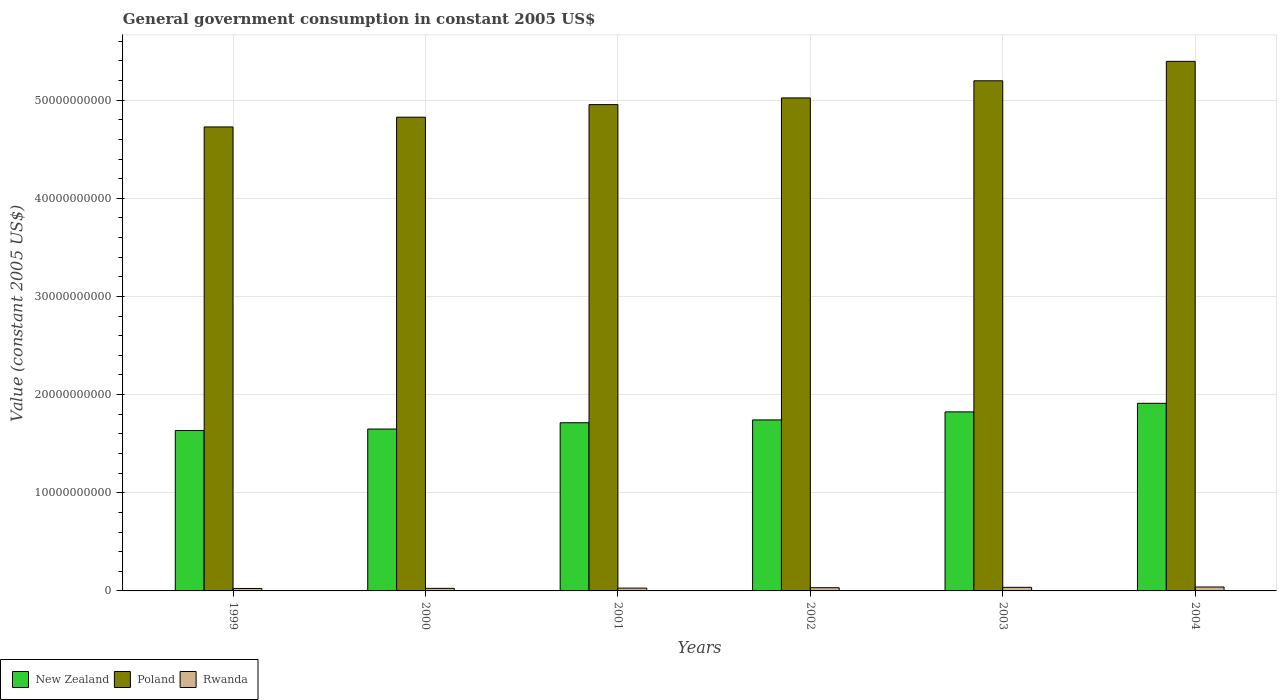How many different coloured bars are there?
Make the answer very short. 3. Are the number of bars per tick equal to the number of legend labels?
Keep it short and to the point. Yes. How many bars are there on the 6th tick from the left?
Your response must be concise. 3. What is the label of the 5th group of bars from the left?
Provide a succinct answer. 2003. What is the government conusmption in Rwanda in 2000?
Ensure brevity in your answer.  2.63e+08. Across all years, what is the maximum government conusmption in Rwanda?
Make the answer very short. 4.01e+08. Across all years, what is the minimum government conusmption in New Zealand?
Your answer should be compact. 1.63e+1. In which year was the government conusmption in New Zealand maximum?
Your answer should be compact. 2004. What is the total government conusmption in Rwanda in the graph?
Make the answer very short. 1.89e+09. What is the difference between the government conusmption in New Zealand in 1999 and that in 2002?
Ensure brevity in your answer.  -1.08e+09. What is the difference between the government conusmption in Rwanda in 1999 and the government conusmption in New Zealand in 2004?
Offer a terse response. -1.89e+1. What is the average government conusmption in New Zealand per year?
Ensure brevity in your answer.  1.75e+1. In the year 2002, what is the difference between the government conusmption in New Zealand and government conusmption in Rwanda?
Your answer should be very brief. 1.71e+1. What is the ratio of the government conusmption in Rwanda in 2001 to that in 2002?
Provide a succinct answer. 0.88. Is the difference between the government conusmption in New Zealand in 1999 and 2004 greater than the difference between the government conusmption in Rwanda in 1999 and 2004?
Your answer should be very brief. No. What is the difference between the highest and the second highest government conusmption in Rwanda?
Offer a very short reply. 3.50e+07. What is the difference between the highest and the lowest government conusmption in Rwanda?
Keep it short and to the point. 1.49e+08. In how many years, is the government conusmption in Rwanda greater than the average government conusmption in Rwanda taken over all years?
Make the answer very short. 3. Is the sum of the government conusmption in New Zealand in 1999 and 2002 greater than the maximum government conusmption in Rwanda across all years?
Give a very brief answer. Yes. What does the 2nd bar from the left in 2001 represents?
Keep it short and to the point. Poland. What does the 3rd bar from the right in 1999 represents?
Give a very brief answer. New Zealand. Are all the bars in the graph horizontal?
Make the answer very short. No. What is the difference between two consecutive major ticks on the Y-axis?
Ensure brevity in your answer.  1.00e+1. Are the values on the major ticks of Y-axis written in scientific E-notation?
Your answer should be very brief. No. Does the graph contain any zero values?
Your answer should be compact. No. Does the graph contain grids?
Provide a short and direct response. Yes. How many legend labels are there?
Make the answer very short. 3. How are the legend labels stacked?
Offer a very short reply. Horizontal. What is the title of the graph?
Give a very brief answer. General government consumption in constant 2005 US$. What is the label or title of the Y-axis?
Ensure brevity in your answer.  Value (constant 2005 US$). What is the Value (constant 2005 US$) of New Zealand in 1999?
Give a very brief answer. 1.63e+1. What is the Value (constant 2005 US$) of Poland in 1999?
Provide a short and direct response. 4.73e+1. What is the Value (constant 2005 US$) of Rwanda in 1999?
Give a very brief answer. 2.51e+08. What is the Value (constant 2005 US$) in New Zealand in 2000?
Offer a terse response. 1.65e+1. What is the Value (constant 2005 US$) of Poland in 2000?
Provide a succinct answer. 4.83e+1. What is the Value (constant 2005 US$) in Rwanda in 2000?
Your answer should be very brief. 2.63e+08. What is the Value (constant 2005 US$) in New Zealand in 2001?
Ensure brevity in your answer.  1.71e+1. What is the Value (constant 2005 US$) in Poland in 2001?
Provide a short and direct response. 4.95e+1. What is the Value (constant 2005 US$) in Rwanda in 2001?
Keep it short and to the point. 2.87e+08. What is the Value (constant 2005 US$) of New Zealand in 2002?
Offer a terse response. 1.74e+1. What is the Value (constant 2005 US$) of Poland in 2002?
Ensure brevity in your answer.  5.02e+1. What is the Value (constant 2005 US$) in Rwanda in 2002?
Your answer should be compact. 3.27e+08. What is the Value (constant 2005 US$) in New Zealand in 2003?
Keep it short and to the point. 1.82e+1. What is the Value (constant 2005 US$) of Poland in 2003?
Your response must be concise. 5.20e+1. What is the Value (constant 2005 US$) in Rwanda in 2003?
Provide a short and direct response. 3.66e+08. What is the Value (constant 2005 US$) in New Zealand in 2004?
Offer a terse response. 1.91e+1. What is the Value (constant 2005 US$) in Poland in 2004?
Provide a short and direct response. 5.39e+1. What is the Value (constant 2005 US$) of Rwanda in 2004?
Your response must be concise. 4.01e+08. Across all years, what is the maximum Value (constant 2005 US$) in New Zealand?
Provide a short and direct response. 1.91e+1. Across all years, what is the maximum Value (constant 2005 US$) in Poland?
Your answer should be very brief. 5.39e+1. Across all years, what is the maximum Value (constant 2005 US$) of Rwanda?
Provide a short and direct response. 4.01e+08. Across all years, what is the minimum Value (constant 2005 US$) of New Zealand?
Keep it short and to the point. 1.63e+1. Across all years, what is the minimum Value (constant 2005 US$) in Poland?
Offer a terse response. 4.73e+1. Across all years, what is the minimum Value (constant 2005 US$) of Rwanda?
Offer a terse response. 2.51e+08. What is the total Value (constant 2005 US$) of New Zealand in the graph?
Make the answer very short. 1.05e+11. What is the total Value (constant 2005 US$) in Poland in the graph?
Provide a short and direct response. 3.01e+11. What is the total Value (constant 2005 US$) in Rwanda in the graph?
Your answer should be compact. 1.89e+09. What is the difference between the Value (constant 2005 US$) of New Zealand in 1999 and that in 2000?
Make the answer very short. -1.54e+08. What is the difference between the Value (constant 2005 US$) of Poland in 1999 and that in 2000?
Ensure brevity in your answer.  -9.93e+08. What is the difference between the Value (constant 2005 US$) of Rwanda in 1999 and that in 2000?
Give a very brief answer. -1.11e+07. What is the difference between the Value (constant 2005 US$) in New Zealand in 1999 and that in 2001?
Offer a terse response. -7.96e+08. What is the difference between the Value (constant 2005 US$) in Poland in 1999 and that in 2001?
Keep it short and to the point. -2.27e+09. What is the difference between the Value (constant 2005 US$) in Rwanda in 1999 and that in 2001?
Offer a terse response. -3.54e+07. What is the difference between the Value (constant 2005 US$) in New Zealand in 1999 and that in 2002?
Your response must be concise. -1.08e+09. What is the difference between the Value (constant 2005 US$) of Poland in 1999 and that in 2002?
Make the answer very short. -2.96e+09. What is the difference between the Value (constant 2005 US$) of Rwanda in 1999 and that in 2002?
Give a very brief answer. -7.56e+07. What is the difference between the Value (constant 2005 US$) in New Zealand in 1999 and that in 2003?
Your answer should be compact. -1.90e+09. What is the difference between the Value (constant 2005 US$) in Poland in 1999 and that in 2003?
Make the answer very short. -4.70e+09. What is the difference between the Value (constant 2005 US$) of Rwanda in 1999 and that in 2003?
Your answer should be very brief. -1.14e+08. What is the difference between the Value (constant 2005 US$) in New Zealand in 1999 and that in 2004?
Keep it short and to the point. -2.77e+09. What is the difference between the Value (constant 2005 US$) of Poland in 1999 and that in 2004?
Provide a succinct answer. -6.68e+09. What is the difference between the Value (constant 2005 US$) of Rwanda in 1999 and that in 2004?
Your answer should be compact. -1.49e+08. What is the difference between the Value (constant 2005 US$) in New Zealand in 2000 and that in 2001?
Provide a short and direct response. -6.42e+08. What is the difference between the Value (constant 2005 US$) of Poland in 2000 and that in 2001?
Offer a terse response. -1.28e+09. What is the difference between the Value (constant 2005 US$) in Rwanda in 2000 and that in 2001?
Your answer should be very brief. -2.43e+07. What is the difference between the Value (constant 2005 US$) of New Zealand in 2000 and that in 2002?
Give a very brief answer. -9.29e+08. What is the difference between the Value (constant 2005 US$) of Poland in 2000 and that in 2002?
Keep it short and to the point. -1.96e+09. What is the difference between the Value (constant 2005 US$) of Rwanda in 2000 and that in 2002?
Ensure brevity in your answer.  -6.45e+07. What is the difference between the Value (constant 2005 US$) of New Zealand in 2000 and that in 2003?
Keep it short and to the point. -1.75e+09. What is the difference between the Value (constant 2005 US$) of Poland in 2000 and that in 2003?
Make the answer very short. -3.71e+09. What is the difference between the Value (constant 2005 US$) in Rwanda in 2000 and that in 2003?
Your answer should be compact. -1.03e+08. What is the difference between the Value (constant 2005 US$) of New Zealand in 2000 and that in 2004?
Make the answer very short. -2.62e+09. What is the difference between the Value (constant 2005 US$) in Poland in 2000 and that in 2004?
Provide a short and direct response. -5.69e+09. What is the difference between the Value (constant 2005 US$) of Rwanda in 2000 and that in 2004?
Make the answer very short. -1.38e+08. What is the difference between the Value (constant 2005 US$) of New Zealand in 2001 and that in 2002?
Make the answer very short. -2.88e+08. What is the difference between the Value (constant 2005 US$) of Poland in 2001 and that in 2002?
Your answer should be very brief. -6.83e+08. What is the difference between the Value (constant 2005 US$) of Rwanda in 2001 and that in 2002?
Keep it short and to the point. -4.02e+07. What is the difference between the Value (constant 2005 US$) of New Zealand in 2001 and that in 2003?
Make the answer very short. -1.11e+09. What is the difference between the Value (constant 2005 US$) of Poland in 2001 and that in 2003?
Make the answer very short. -2.43e+09. What is the difference between the Value (constant 2005 US$) of Rwanda in 2001 and that in 2003?
Give a very brief answer. -7.88e+07. What is the difference between the Value (constant 2005 US$) of New Zealand in 2001 and that in 2004?
Give a very brief answer. -1.98e+09. What is the difference between the Value (constant 2005 US$) in Poland in 2001 and that in 2004?
Your answer should be compact. -4.41e+09. What is the difference between the Value (constant 2005 US$) in Rwanda in 2001 and that in 2004?
Offer a terse response. -1.14e+08. What is the difference between the Value (constant 2005 US$) of New Zealand in 2002 and that in 2003?
Your answer should be compact. -8.18e+08. What is the difference between the Value (constant 2005 US$) in Poland in 2002 and that in 2003?
Provide a short and direct response. -1.74e+09. What is the difference between the Value (constant 2005 US$) in Rwanda in 2002 and that in 2003?
Offer a very short reply. -3.86e+07. What is the difference between the Value (constant 2005 US$) in New Zealand in 2002 and that in 2004?
Give a very brief answer. -1.69e+09. What is the difference between the Value (constant 2005 US$) of Poland in 2002 and that in 2004?
Make the answer very short. -3.72e+09. What is the difference between the Value (constant 2005 US$) of Rwanda in 2002 and that in 2004?
Make the answer very short. -7.36e+07. What is the difference between the Value (constant 2005 US$) of New Zealand in 2003 and that in 2004?
Provide a short and direct response. -8.72e+08. What is the difference between the Value (constant 2005 US$) of Poland in 2003 and that in 2004?
Provide a short and direct response. -1.98e+09. What is the difference between the Value (constant 2005 US$) in Rwanda in 2003 and that in 2004?
Your response must be concise. -3.50e+07. What is the difference between the Value (constant 2005 US$) in New Zealand in 1999 and the Value (constant 2005 US$) in Poland in 2000?
Your answer should be very brief. -3.19e+1. What is the difference between the Value (constant 2005 US$) of New Zealand in 1999 and the Value (constant 2005 US$) of Rwanda in 2000?
Ensure brevity in your answer.  1.61e+1. What is the difference between the Value (constant 2005 US$) in Poland in 1999 and the Value (constant 2005 US$) in Rwanda in 2000?
Keep it short and to the point. 4.70e+1. What is the difference between the Value (constant 2005 US$) in New Zealand in 1999 and the Value (constant 2005 US$) in Poland in 2001?
Your answer should be compact. -3.32e+1. What is the difference between the Value (constant 2005 US$) of New Zealand in 1999 and the Value (constant 2005 US$) of Rwanda in 2001?
Give a very brief answer. 1.61e+1. What is the difference between the Value (constant 2005 US$) in Poland in 1999 and the Value (constant 2005 US$) in Rwanda in 2001?
Provide a succinct answer. 4.70e+1. What is the difference between the Value (constant 2005 US$) in New Zealand in 1999 and the Value (constant 2005 US$) in Poland in 2002?
Ensure brevity in your answer.  -3.39e+1. What is the difference between the Value (constant 2005 US$) of New Zealand in 1999 and the Value (constant 2005 US$) of Rwanda in 2002?
Provide a succinct answer. 1.60e+1. What is the difference between the Value (constant 2005 US$) of Poland in 1999 and the Value (constant 2005 US$) of Rwanda in 2002?
Keep it short and to the point. 4.69e+1. What is the difference between the Value (constant 2005 US$) of New Zealand in 1999 and the Value (constant 2005 US$) of Poland in 2003?
Your answer should be very brief. -3.56e+1. What is the difference between the Value (constant 2005 US$) of New Zealand in 1999 and the Value (constant 2005 US$) of Rwanda in 2003?
Provide a short and direct response. 1.60e+1. What is the difference between the Value (constant 2005 US$) in Poland in 1999 and the Value (constant 2005 US$) in Rwanda in 2003?
Your answer should be very brief. 4.69e+1. What is the difference between the Value (constant 2005 US$) of New Zealand in 1999 and the Value (constant 2005 US$) of Poland in 2004?
Offer a terse response. -3.76e+1. What is the difference between the Value (constant 2005 US$) of New Zealand in 1999 and the Value (constant 2005 US$) of Rwanda in 2004?
Your response must be concise. 1.59e+1. What is the difference between the Value (constant 2005 US$) of Poland in 1999 and the Value (constant 2005 US$) of Rwanda in 2004?
Offer a very short reply. 4.69e+1. What is the difference between the Value (constant 2005 US$) of New Zealand in 2000 and the Value (constant 2005 US$) of Poland in 2001?
Make the answer very short. -3.30e+1. What is the difference between the Value (constant 2005 US$) of New Zealand in 2000 and the Value (constant 2005 US$) of Rwanda in 2001?
Provide a succinct answer. 1.62e+1. What is the difference between the Value (constant 2005 US$) of Poland in 2000 and the Value (constant 2005 US$) of Rwanda in 2001?
Provide a short and direct response. 4.80e+1. What is the difference between the Value (constant 2005 US$) of New Zealand in 2000 and the Value (constant 2005 US$) of Poland in 2002?
Your response must be concise. -3.37e+1. What is the difference between the Value (constant 2005 US$) in New Zealand in 2000 and the Value (constant 2005 US$) in Rwanda in 2002?
Offer a terse response. 1.62e+1. What is the difference between the Value (constant 2005 US$) in Poland in 2000 and the Value (constant 2005 US$) in Rwanda in 2002?
Give a very brief answer. 4.79e+1. What is the difference between the Value (constant 2005 US$) in New Zealand in 2000 and the Value (constant 2005 US$) in Poland in 2003?
Ensure brevity in your answer.  -3.55e+1. What is the difference between the Value (constant 2005 US$) in New Zealand in 2000 and the Value (constant 2005 US$) in Rwanda in 2003?
Ensure brevity in your answer.  1.61e+1. What is the difference between the Value (constant 2005 US$) of Poland in 2000 and the Value (constant 2005 US$) of Rwanda in 2003?
Give a very brief answer. 4.79e+1. What is the difference between the Value (constant 2005 US$) of New Zealand in 2000 and the Value (constant 2005 US$) of Poland in 2004?
Your answer should be compact. -3.75e+1. What is the difference between the Value (constant 2005 US$) of New Zealand in 2000 and the Value (constant 2005 US$) of Rwanda in 2004?
Offer a very short reply. 1.61e+1. What is the difference between the Value (constant 2005 US$) of Poland in 2000 and the Value (constant 2005 US$) of Rwanda in 2004?
Make the answer very short. 4.79e+1. What is the difference between the Value (constant 2005 US$) of New Zealand in 2001 and the Value (constant 2005 US$) of Poland in 2002?
Ensure brevity in your answer.  -3.31e+1. What is the difference between the Value (constant 2005 US$) in New Zealand in 2001 and the Value (constant 2005 US$) in Rwanda in 2002?
Ensure brevity in your answer.  1.68e+1. What is the difference between the Value (constant 2005 US$) in Poland in 2001 and the Value (constant 2005 US$) in Rwanda in 2002?
Ensure brevity in your answer.  4.92e+1. What is the difference between the Value (constant 2005 US$) of New Zealand in 2001 and the Value (constant 2005 US$) of Poland in 2003?
Give a very brief answer. -3.48e+1. What is the difference between the Value (constant 2005 US$) of New Zealand in 2001 and the Value (constant 2005 US$) of Rwanda in 2003?
Offer a very short reply. 1.68e+1. What is the difference between the Value (constant 2005 US$) of Poland in 2001 and the Value (constant 2005 US$) of Rwanda in 2003?
Make the answer very short. 4.92e+1. What is the difference between the Value (constant 2005 US$) of New Zealand in 2001 and the Value (constant 2005 US$) of Poland in 2004?
Offer a very short reply. -3.68e+1. What is the difference between the Value (constant 2005 US$) in New Zealand in 2001 and the Value (constant 2005 US$) in Rwanda in 2004?
Provide a succinct answer. 1.67e+1. What is the difference between the Value (constant 2005 US$) of Poland in 2001 and the Value (constant 2005 US$) of Rwanda in 2004?
Your answer should be compact. 4.91e+1. What is the difference between the Value (constant 2005 US$) in New Zealand in 2002 and the Value (constant 2005 US$) in Poland in 2003?
Give a very brief answer. -3.45e+1. What is the difference between the Value (constant 2005 US$) in New Zealand in 2002 and the Value (constant 2005 US$) in Rwanda in 2003?
Provide a succinct answer. 1.71e+1. What is the difference between the Value (constant 2005 US$) in Poland in 2002 and the Value (constant 2005 US$) in Rwanda in 2003?
Your response must be concise. 4.99e+1. What is the difference between the Value (constant 2005 US$) of New Zealand in 2002 and the Value (constant 2005 US$) of Poland in 2004?
Your answer should be very brief. -3.65e+1. What is the difference between the Value (constant 2005 US$) of New Zealand in 2002 and the Value (constant 2005 US$) of Rwanda in 2004?
Provide a short and direct response. 1.70e+1. What is the difference between the Value (constant 2005 US$) in Poland in 2002 and the Value (constant 2005 US$) in Rwanda in 2004?
Provide a succinct answer. 4.98e+1. What is the difference between the Value (constant 2005 US$) in New Zealand in 2003 and the Value (constant 2005 US$) in Poland in 2004?
Ensure brevity in your answer.  -3.57e+1. What is the difference between the Value (constant 2005 US$) in New Zealand in 2003 and the Value (constant 2005 US$) in Rwanda in 2004?
Provide a short and direct response. 1.78e+1. What is the difference between the Value (constant 2005 US$) of Poland in 2003 and the Value (constant 2005 US$) of Rwanda in 2004?
Offer a terse response. 5.16e+1. What is the average Value (constant 2005 US$) in New Zealand per year?
Ensure brevity in your answer.  1.75e+1. What is the average Value (constant 2005 US$) in Poland per year?
Your answer should be compact. 5.02e+1. What is the average Value (constant 2005 US$) of Rwanda per year?
Offer a very short reply. 3.16e+08. In the year 1999, what is the difference between the Value (constant 2005 US$) of New Zealand and Value (constant 2005 US$) of Poland?
Keep it short and to the point. -3.09e+1. In the year 1999, what is the difference between the Value (constant 2005 US$) of New Zealand and Value (constant 2005 US$) of Rwanda?
Offer a very short reply. 1.61e+1. In the year 1999, what is the difference between the Value (constant 2005 US$) of Poland and Value (constant 2005 US$) of Rwanda?
Offer a terse response. 4.70e+1. In the year 2000, what is the difference between the Value (constant 2005 US$) of New Zealand and Value (constant 2005 US$) of Poland?
Give a very brief answer. -3.18e+1. In the year 2000, what is the difference between the Value (constant 2005 US$) in New Zealand and Value (constant 2005 US$) in Rwanda?
Your response must be concise. 1.62e+1. In the year 2000, what is the difference between the Value (constant 2005 US$) of Poland and Value (constant 2005 US$) of Rwanda?
Provide a short and direct response. 4.80e+1. In the year 2001, what is the difference between the Value (constant 2005 US$) in New Zealand and Value (constant 2005 US$) in Poland?
Your answer should be compact. -3.24e+1. In the year 2001, what is the difference between the Value (constant 2005 US$) of New Zealand and Value (constant 2005 US$) of Rwanda?
Your answer should be very brief. 1.68e+1. In the year 2001, what is the difference between the Value (constant 2005 US$) in Poland and Value (constant 2005 US$) in Rwanda?
Offer a terse response. 4.93e+1. In the year 2002, what is the difference between the Value (constant 2005 US$) in New Zealand and Value (constant 2005 US$) in Poland?
Offer a terse response. -3.28e+1. In the year 2002, what is the difference between the Value (constant 2005 US$) in New Zealand and Value (constant 2005 US$) in Rwanda?
Your answer should be very brief. 1.71e+1. In the year 2002, what is the difference between the Value (constant 2005 US$) in Poland and Value (constant 2005 US$) in Rwanda?
Make the answer very short. 4.99e+1. In the year 2003, what is the difference between the Value (constant 2005 US$) of New Zealand and Value (constant 2005 US$) of Poland?
Offer a very short reply. -3.37e+1. In the year 2003, what is the difference between the Value (constant 2005 US$) in New Zealand and Value (constant 2005 US$) in Rwanda?
Give a very brief answer. 1.79e+1. In the year 2003, what is the difference between the Value (constant 2005 US$) of Poland and Value (constant 2005 US$) of Rwanda?
Provide a short and direct response. 5.16e+1. In the year 2004, what is the difference between the Value (constant 2005 US$) of New Zealand and Value (constant 2005 US$) of Poland?
Your answer should be very brief. -3.48e+1. In the year 2004, what is the difference between the Value (constant 2005 US$) of New Zealand and Value (constant 2005 US$) of Rwanda?
Provide a succinct answer. 1.87e+1. In the year 2004, what is the difference between the Value (constant 2005 US$) in Poland and Value (constant 2005 US$) in Rwanda?
Your response must be concise. 5.35e+1. What is the ratio of the Value (constant 2005 US$) in New Zealand in 1999 to that in 2000?
Your response must be concise. 0.99. What is the ratio of the Value (constant 2005 US$) of Poland in 1999 to that in 2000?
Your answer should be compact. 0.98. What is the ratio of the Value (constant 2005 US$) of Rwanda in 1999 to that in 2000?
Provide a short and direct response. 0.96. What is the ratio of the Value (constant 2005 US$) in New Zealand in 1999 to that in 2001?
Give a very brief answer. 0.95. What is the ratio of the Value (constant 2005 US$) of Poland in 1999 to that in 2001?
Provide a succinct answer. 0.95. What is the ratio of the Value (constant 2005 US$) of Rwanda in 1999 to that in 2001?
Offer a terse response. 0.88. What is the ratio of the Value (constant 2005 US$) of New Zealand in 1999 to that in 2002?
Offer a terse response. 0.94. What is the ratio of the Value (constant 2005 US$) of Poland in 1999 to that in 2002?
Your response must be concise. 0.94. What is the ratio of the Value (constant 2005 US$) in Rwanda in 1999 to that in 2002?
Your answer should be compact. 0.77. What is the ratio of the Value (constant 2005 US$) in New Zealand in 1999 to that in 2003?
Give a very brief answer. 0.9. What is the ratio of the Value (constant 2005 US$) in Poland in 1999 to that in 2003?
Ensure brevity in your answer.  0.91. What is the ratio of the Value (constant 2005 US$) in Rwanda in 1999 to that in 2003?
Offer a very short reply. 0.69. What is the ratio of the Value (constant 2005 US$) of New Zealand in 1999 to that in 2004?
Your answer should be very brief. 0.85. What is the ratio of the Value (constant 2005 US$) in Poland in 1999 to that in 2004?
Make the answer very short. 0.88. What is the ratio of the Value (constant 2005 US$) of Rwanda in 1999 to that in 2004?
Your response must be concise. 0.63. What is the ratio of the Value (constant 2005 US$) in New Zealand in 2000 to that in 2001?
Make the answer very short. 0.96. What is the ratio of the Value (constant 2005 US$) in Poland in 2000 to that in 2001?
Give a very brief answer. 0.97. What is the ratio of the Value (constant 2005 US$) of Rwanda in 2000 to that in 2001?
Make the answer very short. 0.92. What is the ratio of the Value (constant 2005 US$) in New Zealand in 2000 to that in 2002?
Make the answer very short. 0.95. What is the ratio of the Value (constant 2005 US$) in Poland in 2000 to that in 2002?
Your response must be concise. 0.96. What is the ratio of the Value (constant 2005 US$) in Rwanda in 2000 to that in 2002?
Your answer should be very brief. 0.8. What is the ratio of the Value (constant 2005 US$) in New Zealand in 2000 to that in 2003?
Provide a succinct answer. 0.9. What is the ratio of the Value (constant 2005 US$) of Poland in 2000 to that in 2003?
Offer a very short reply. 0.93. What is the ratio of the Value (constant 2005 US$) of Rwanda in 2000 to that in 2003?
Your answer should be compact. 0.72. What is the ratio of the Value (constant 2005 US$) of New Zealand in 2000 to that in 2004?
Your answer should be very brief. 0.86. What is the ratio of the Value (constant 2005 US$) of Poland in 2000 to that in 2004?
Provide a short and direct response. 0.89. What is the ratio of the Value (constant 2005 US$) of Rwanda in 2000 to that in 2004?
Provide a succinct answer. 0.66. What is the ratio of the Value (constant 2005 US$) of New Zealand in 2001 to that in 2002?
Offer a terse response. 0.98. What is the ratio of the Value (constant 2005 US$) in Poland in 2001 to that in 2002?
Your answer should be compact. 0.99. What is the ratio of the Value (constant 2005 US$) in Rwanda in 2001 to that in 2002?
Give a very brief answer. 0.88. What is the ratio of the Value (constant 2005 US$) of New Zealand in 2001 to that in 2003?
Provide a short and direct response. 0.94. What is the ratio of the Value (constant 2005 US$) in Poland in 2001 to that in 2003?
Keep it short and to the point. 0.95. What is the ratio of the Value (constant 2005 US$) of Rwanda in 2001 to that in 2003?
Keep it short and to the point. 0.78. What is the ratio of the Value (constant 2005 US$) in New Zealand in 2001 to that in 2004?
Make the answer very short. 0.9. What is the ratio of the Value (constant 2005 US$) in Poland in 2001 to that in 2004?
Your response must be concise. 0.92. What is the ratio of the Value (constant 2005 US$) of Rwanda in 2001 to that in 2004?
Give a very brief answer. 0.72. What is the ratio of the Value (constant 2005 US$) of New Zealand in 2002 to that in 2003?
Your answer should be compact. 0.96. What is the ratio of the Value (constant 2005 US$) of Poland in 2002 to that in 2003?
Give a very brief answer. 0.97. What is the ratio of the Value (constant 2005 US$) in Rwanda in 2002 to that in 2003?
Provide a succinct answer. 0.89. What is the ratio of the Value (constant 2005 US$) in New Zealand in 2002 to that in 2004?
Make the answer very short. 0.91. What is the ratio of the Value (constant 2005 US$) in Rwanda in 2002 to that in 2004?
Your response must be concise. 0.82. What is the ratio of the Value (constant 2005 US$) of New Zealand in 2003 to that in 2004?
Ensure brevity in your answer.  0.95. What is the ratio of the Value (constant 2005 US$) in Poland in 2003 to that in 2004?
Your response must be concise. 0.96. What is the ratio of the Value (constant 2005 US$) in Rwanda in 2003 to that in 2004?
Ensure brevity in your answer.  0.91. What is the difference between the highest and the second highest Value (constant 2005 US$) of New Zealand?
Your response must be concise. 8.72e+08. What is the difference between the highest and the second highest Value (constant 2005 US$) of Poland?
Provide a succinct answer. 1.98e+09. What is the difference between the highest and the second highest Value (constant 2005 US$) in Rwanda?
Offer a very short reply. 3.50e+07. What is the difference between the highest and the lowest Value (constant 2005 US$) in New Zealand?
Ensure brevity in your answer.  2.77e+09. What is the difference between the highest and the lowest Value (constant 2005 US$) of Poland?
Your response must be concise. 6.68e+09. What is the difference between the highest and the lowest Value (constant 2005 US$) in Rwanda?
Give a very brief answer. 1.49e+08. 